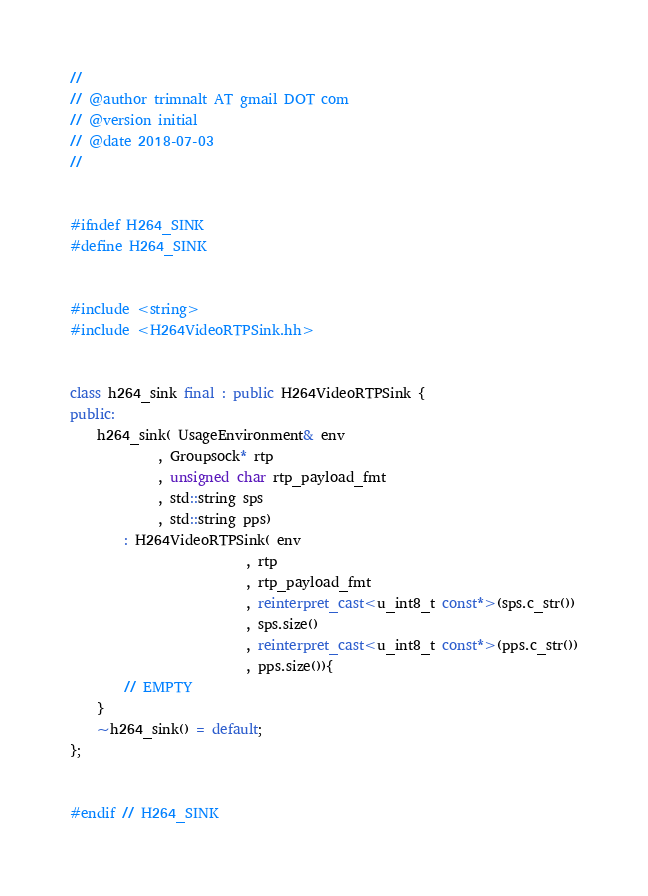Convert code to text. <code><loc_0><loc_0><loc_500><loc_500><_C++_>//
// @author trimnalt AT gmail DOT com
// @version initial
// @date 2018-07-03
//


#ifndef H264_SINK
#define H264_SINK


#include <string>
#include <H264VideoRTPSink.hh>


class h264_sink final : public H264VideoRTPSink {
public:
    h264_sink( UsageEnvironment& env
             , Groupsock* rtp
             , unsigned char rtp_payload_fmt
             , std::string sps
             , std::string pps)
        : H264VideoRTPSink( env
                          , rtp
                          , rtp_payload_fmt
                          , reinterpret_cast<u_int8_t const*>(sps.c_str())
                          , sps.size()
                          , reinterpret_cast<u_int8_t const*>(pps.c_str())
                          , pps.size()){
        // EMPTY
    }
    ~h264_sink() = default;
};


#endif // H264_SINK
</code> 